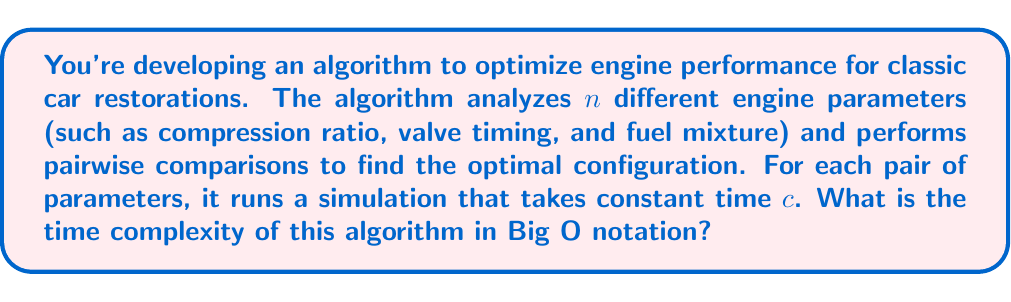Help me with this question. To solve this problem, let's break it down step-by-step:

1) First, we need to understand what the algorithm is doing. It's comparing every parameter with every other parameter. This is essentially a pairwise comparison of all parameters.

2) In combinatorics, the number of ways to choose 2 items from n items is given by the combination formula:

   $$\binom{n}{2} = \frac{n!}{2!(n-2)!} = \frac{n(n-1)}{2}$$

3) Each of these comparisons involves running a simulation that takes constant time $c$. So, the total time taken will be:

   $$T(n) = c \cdot \frac{n(n-1)}{2}$$

4) Expanding this:

   $$T(n) = \frac{cn^2 - cn}{2}$$

5) In Big O notation, we're interested in the growth rate as $n$ becomes very large. The highest order term dominates, so we can ignore lower order terms and constants:

   $$T(n) = O(n^2)$$

6) This makes sense intuitively: as we increase the number of parameters, the number of comparisons grows quadratically.

Therefore, the time complexity of this algorithm is $O(n^2)$.
Answer: $O(n^2)$ 